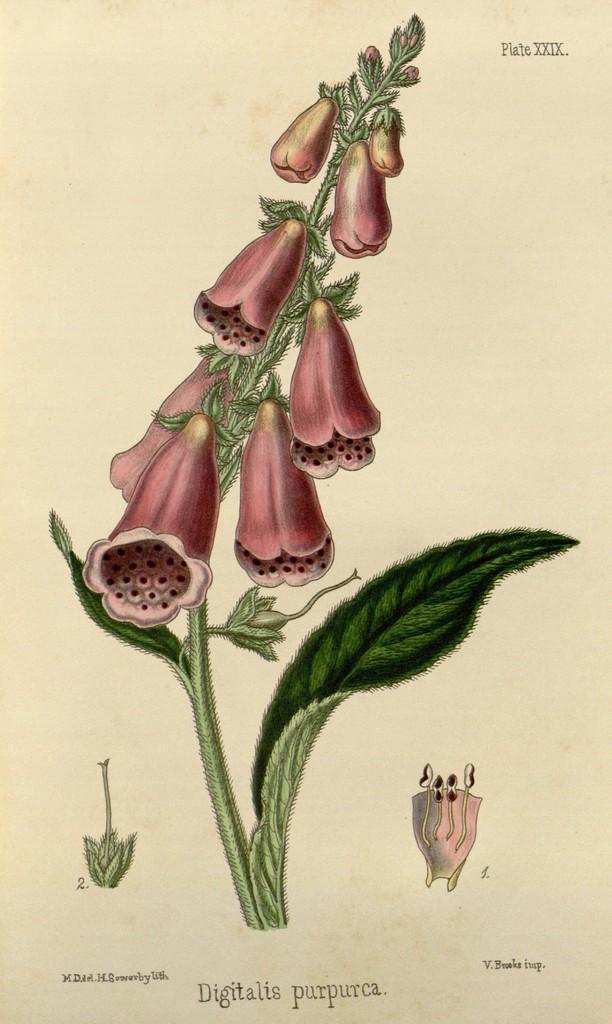Please provide a concise description of this image. In this image, we can see a sketch of a plant and there are flowers and some text on the paper. 